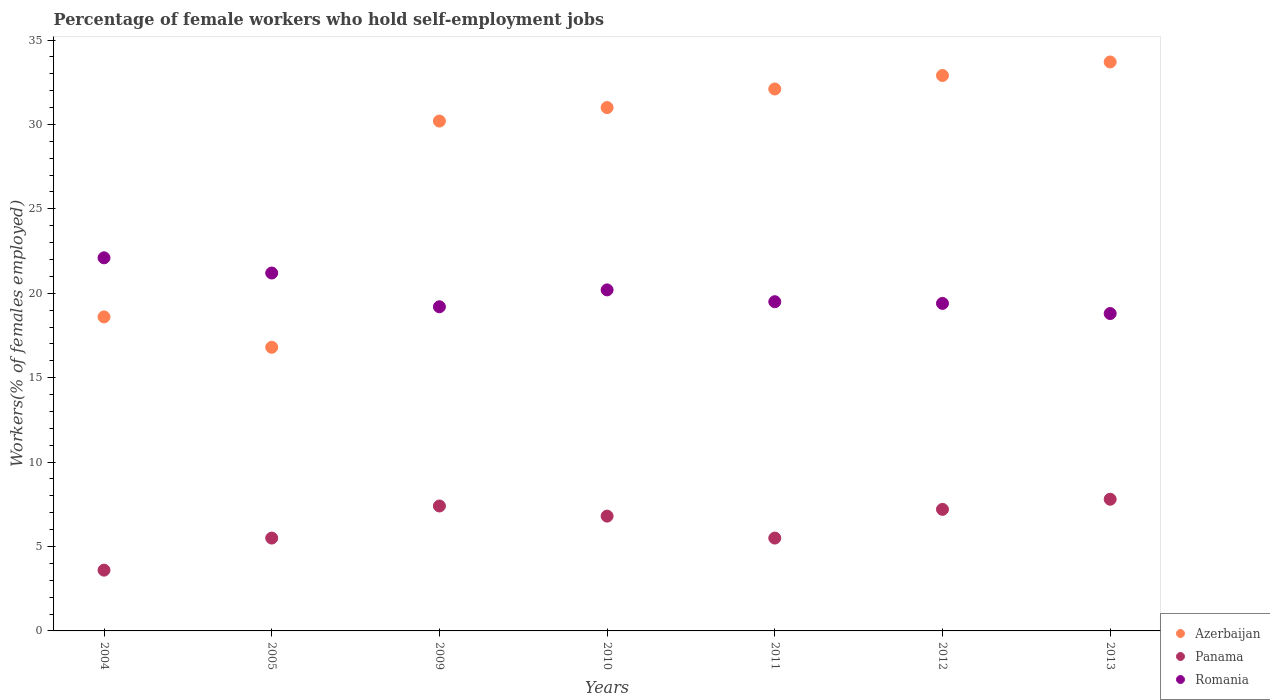Across all years, what is the maximum percentage of self-employed female workers in Panama?
Make the answer very short. 7.8. Across all years, what is the minimum percentage of self-employed female workers in Romania?
Offer a terse response. 18.8. In which year was the percentage of self-employed female workers in Romania maximum?
Offer a very short reply. 2004. What is the total percentage of self-employed female workers in Azerbaijan in the graph?
Give a very brief answer. 195.3. What is the difference between the percentage of self-employed female workers in Panama in 2011 and that in 2012?
Your answer should be very brief. -1.7. What is the difference between the percentage of self-employed female workers in Panama in 2011 and the percentage of self-employed female workers in Romania in 2009?
Give a very brief answer. -13.7. What is the average percentage of self-employed female workers in Panama per year?
Provide a short and direct response. 6.26. In the year 2013, what is the difference between the percentage of self-employed female workers in Azerbaijan and percentage of self-employed female workers in Panama?
Your response must be concise. 25.9. What is the ratio of the percentage of self-employed female workers in Romania in 2011 to that in 2012?
Provide a short and direct response. 1.01. Is the percentage of self-employed female workers in Romania in 2005 less than that in 2009?
Provide a succinct answer. No. What is the difference between the highest and the second highest percentage of self-employed female workers in Azerbaijan?
Your response must be concise. 0.8. What is the difference between the highest and the lowest percentage of self-employed female workers in Panama?
Ensure brevity in your answer.  4.2. In how many years, is the percentage of self-employed female workers in Panama greater than the average percentage of self-employed female workers in Panama taken over all years?
Offer a terse response. 4. Does the percentage of self-employed female workers in Romania monotonically increase over the years?
Your response must be concise. No. Is the percentage of self-employed female workers in Azerbaijan strictly greater than the percentage of self-employed female workers in Panama over the years?
Offer a terse response. Yes. Is the percentage of self-employed female workers in Panama strictly less than the percentage of self-employed female workers in Romania over the years?
Ensure brevity in your answer.  Yes. How many years are there in the graph?
Ensure brevity in your answer.  7. Are the values on the major ticks of Y-axis written in scientific E-notation?
Your answer should be very brief. No. Where does the legend appear in the graph?
Ensure brevity in your answer.  Bottom right. How many legend labels are there?
Provide a short and direct response. 3. How are the legend labels stacked?
Give a very brief answer. Vertical. What is the title of the graph?
Ensure brevity in your answer.  Percentage of female workers who hold self-employment jobs. What is the label or title of the Y-axis?
Give a very brief answer. Workers(% of females employed). What is the Workers(% of females employed) in Azerbaijan in 2004?
Your answer should be compact. 18.6. What is the Workers(% of females employed) of Panama in 2004?
Your answer should be very brief. 3.6. What is the Workers(% of females employed) of Romania in 2004?
Give a very brief answer. 22.1. What is the Workers(% of females employed) in Azerbaijan in 2005?
Provide a short and direct response. 16.8. What is the Workers(% of females employed) of Romania in 2005?
Provide a short and direct response. 21.2. What is the Workers(% of females employed) in Azerbaijan in 2009?
Offer a very short reply. 30.2. What is the Workers(% of females employed) in Panama in 2009?
Make the answer very short. 7.4. What is the Workers(% of females employed) of Romania in 2009?
Offer a very short reply. 19.2. What is the Workers(% of females employed) in Panama in 2010?
Ensure brevity in your answer.  6.8. What is the Workers(% of females employed) of Romania in 2010?
Offer a terse response. 20.2. What is the Workers(% of females employed) of Azerbaijan in 2011?
Provide a short and direct response. 32.1. What is the Workers(% of females employed) in Azerbaijan in 2012?
Ensure brevity in your answer.  32.9. What is the Workers(% of females employed) of Panama in 2012?
Your response must be concise. 7.2. What is the Workers(% of females employed) in Romania in 2012?
Ensure brevity in your answer.  19.4. What is the Workers(% of females employed) of Azerbaijan in 2013?
Provide a short and direct response. 33.7. What is the Workers(% of females employed) in Panama in 2013?
Your response must be concise. 7.8. What is the Workers(% of females employed) of Romania in 2013?
Ensure brevity in your answer.  18.8. Across all years, what is the maximum Workers(% of females employed) in Azerbaijan?
Your response must be concise. 33.7. Across all years, what is the maximum Workers(% of females employed) of Panama?
Ensure brevity in your answer.  7.8. Across all years, what is the maximum Workers(% of females employed) of Romania?
Make the answer very short. 22.1. Across all years, what is the minimum Workers(% of females employed) in Azerbaijan?
Offer a very short reply. 16.8. Across all years, what is the minimum Workers(% of females employed) in Panama?
Ensure brevity in your answer.  3.6. Across all years, what is the minimum Workers(% of females employed) in Romania?
Your response must be concise. 18.8. What is the total Workers(% of females employed) of Azerbaijan in the graph?
Keep it short and to the point. 195.3. What is the total Workers(% of females employed) in Panama in the graph?
Your answer should be compact. 43.8. What is the total Workers(% of females employed) of Romania in the graph?
Provide a succinct answer. 140.4. What is the difference between the Workers(% of females employed) in Panama in 2004 and that in 2005?
Keep it short and to the point. -1.9. What is the difference between the Workers(% of females employed) in Azerbaijan in 2004 and that in 2010?
Your response must be concise. -12.4. What is the difference between the Workers(% of females employed) in Romania in 2004 and that in 2010?
Offer a terse response. 1.9. What is the difference between the Workers(% of females employed) in Romania in 2004 and that in 2011?
Keep it short and to the point. 2.6. What is the difference between the Workers(% of females employed) of Azerbaijan in 2004 and that in 2012?
Keep it short and to the point. -14.3. What is the difference between the Workers(% of females employed) of Romania in 2004 and that in 2012?
Provide a succinct answer. 2.7. What is the difference between the Workers(% of females employed) of Azerbaijan in 2004 and that in 2013?
Your answer should be compact. -15.1. What is the difference between the Workers(% of females employed) of Panama in 2004 and that in 2013?
Keep it short and to the point. -4.2. What is the difference between the Workers(% of females employed) in Romania in 2004 and that in 2013?
Your answer should be compact. 3.3. What is the difference between the Workers(% of females employed) of Romania in 2005 and that in 2009?
Offer a very short reply. 2. What is the difference between the Workers(% of females employed) in Romania in 2005 and that in 2010?
Make the answer very short. 1. What is the difference between the Workers(% of females employed) in Azerbaijan in 2005 and that in 2011?
Provide a succinct answer. -15.3. What is the difference between the Workers(% of females employed) in Panama in 2005 and that in 2011?
Provide a succinct answer. 0. What is the difference between the Workers(% of females employed) of Azerbaijan in 2005 and that in 2012?
Your response must be concise. -16.1. What is the difference between the Workers(% of females employed) in Panama in 2005 and that in 2012?
Make the answer very short. -1.7. What is the difference between the Workers(% of females employed) in Azerbaijan in 2005 and that in 2013?
Your answer should be very brief. -16.9. What is the difference between the Workers(% of females employed) of Panama in 2005 and that in 2013?
Your answer should be compact. -2.3. What is the difference between the Workers(% of females employed) in Romania in 2005 and that in 2013?
Your answer should be very brief. 2.4. What is the difference between the Workers(% of females employed) in Romania in 2009 and that in 2012?
Offer a terse response. -0.2. What is the difference between the Workers(% of females employed) of Azerbaijan in 2009 and that in 2013?
Your answer should be compact. -3.5. What is the difference between the Workers(% of females employed) in Panama in 2009 and that in 2013?
Make the answer very short. -0.4. What is the difference between the Workers(% of females employed) in Romania in 2009 and that in 2013?
Give a very brief answer. 0.4. What is the difference between the Workers(% of females employed) of Azerbaijan in 2010 and that in 2011?
Ensure brevity in your answer.  -1.1. What is the difference between the Workers(% of females employed) of Panama in 2010 and that in 2011?
Offer a very short reply. 1.3. What is the difference between the Workers(% of females employed) of Romania in 2010 and that in 2011?
Keep it short and to the point. 0.7. What is the difference between the Workers(% of females employed) in Panama in 2010 and that in 2012?
Make the answer very short. -0.4. What is the difference between the Workers(% of females employed) of Azerbaijan in 2010 and that in 2013?
Provide a succinct answer. -2.7. What is the difference between the Workers(% of females employed) in Azerbaijan in 2011 and that in 2013?
Offer a very short reply. -1.6. What is the difference between the Workers(% of females employed) of Panama in 2011 and that in 2013?
Make the answer very short. -2.3. What is the difference between the Workers(% of females employed) of Romania in 2011 and that in 2013?
Offer a very short reply. 0.7. What is the difference between the Workers(% of females employed) of Azerbaijan in 2012 and that in 2013?
Give a very brief answer. -0.8. What is the difference between the Workers(% of females employed) of Azerbaijan in 2004 and the Workers(% of females employed) of Romania in 2005?
Provide a short and direct response. -2.6. What is the difference between the Workers(% of females employed) of Panama in 2004 and the Workers(% of females employed) of Romania in 2005?
Keep it short and to the point. -17.6. What is the difference between the Workers(% of females employed) in Panama in 2004 and the Workers(% of females employed) in Romania in 2009?
Give a very brief answer. -15.6. What is the difference between the Workers(% of females employed) of Azerbaijan in 2004 and the Workers(% of females employed) of Panama in 2010?
Ensure brevity in your answer.  11.8. What is the difference between the Workers(% of females employed) of Panama in 2004 and the Workers(% of females employed) of Romania in 2010?
Your answer should be compact. -16.6. What is the difference between the Workers(% of females employed) of Azerbaijan in 2004 and the Workers(% of females employed) of Panama in 2011?
Ensure brevity in your answer.  13.1. What is the difference between the Workers(% of females employed) in Azerbaijan in 2004 and the Workers(% of females employed) in Romania in 2011?
Your response must be concise. -0.9. What is the difference between the Workers(% of females employed) of Panama in 2004 and the Workers(% of females employed) of Romania in 2011?
Give a very brief answer. -15.9. What is the difference between the Workers(% of females employed) in Panama in 2004 and the Workers(% of females employed) in Romania in 2012?
Your answer should be very brief. -15.8. What is the difference between the Workers(% of females employed) of Panama in 2004 and the Workers(% of females employed) of Romania in 2013?
Your response must be concise. -15.2. What is the difference between the Workers(% of females employed) of Azerbaijan in 2005 and the Workers(% of females employed) of Romania in 2009?
Give a very brief answer. -2.4. What is the difference between the Workers(% of females employed) in Panama in 2005 and the Workers(% of females employed) in Romania in 2009?
Give a very brief answer. -13.7. What is the difference between the Workers(% of females employed) of Azerbaijan in 2005 and the Workers(% of females employed) of Romania in 2010?
Your response must be concise. -3.4. What is the difference between the Workers(% of females employed) in Panama in 2005 and the Workers(% of females employed) in Romania in 2010?
Your response must be concise. -14.7. What is the difference between the Workers(% of females employed) of Azerbaijan in 2005 and the Workers(% of females employed) of Romania in 2011?
Give a very brief answer. -2.7. What is the difference between the Workers(% of females employed) of Azerbaijan in 2005 and the Workers(% of females employed) of Romania in 2012?
Give a very brief answer. -2.6. What is the difference between the Workers(% of females employed) in Azerbaijan in 2005 and the Workers(% of females employed) in Panama in 2013?
Offer a very short reply. 9. What is the difference between the Workers(% of females employed) of Azerbaijan in 2005 and the Workers(% of females employed) of Romania in 2013?
Your answer should be very brief. -2. What is the difference between the Workers(% of females employed) of Azerbaijan in 2009 and the Workers(% of females employed) of Panama in 2010?
Provide a succinct answer. 23.4. What is the difference between the Workers(% of females employed) of Azerbaijan in 2009 and the Workers(% of females employed) of Romania in 2010?
Provide a succinct answer. 10. What is the difference between the Workers(% of females employed) of Azerbaijan in 2009 and the Workers(% of females employed) of Panama in 2011?
Provide a succinct answer. 24.7. What is the difference between the Workers(% of females employed) of Azerbaijan in 2009 and the Workers(% of females employed) of Panama in 2012?
Your answer should be very brief. 23. What is the difference between the Workers(% of females employed) of Azerbaijan in 2009 and the Workers(% of females employed) of Romania in 2012?
Offer a terse response. 10.8. What is the difference between the Workers(% of females employed) in Azerbaijan in 2009 and the Workers(% of females employed) in Panama in 2013?
Provide a succinct answer. 22.4. What is the difference between the Workers(% of females employed) in Azerbaijan in 2009 and the Workers(% of females employed) in Romania in 2013?
Provide a succinct answer. 11.4. What is the difference between the Workers(% of females employed) of Azerbaijan in 2010 and the Workers(% of females employed) of Romania in 2011?
Your answer should be compact. 11.5. What is the difference between the Workers(% of females employed) of Panama in 2010 and the Workers(% of females employed) of Romania in 2011?
Your response must be concise. -12.7. What is the difference between the Workers(% of females employed) in Azerbaijan in 2010 and the Workers(% of females employed) in Panama in 2012?
Make the answer very short. 23.8. What is the difference between the Workers(% of females employed) of Azerbaijan in 2010 and the Workers(% of females employed) of Romania in 2012?
Provide a succinct answer. 11.6. What is the difference between the Workers(% of females employed) of Panama in 2010 and the Workers(% of females employed) of Romania in 2012?
Make the answer very short. -12.6. What is the difference between the Workers(% of females employed) of Azerbaijan in 2010 and the Workers(% of females employed) of Panama in 2013?
Offer a terse response. 23.2. What is the difference between the Workers(% of females employed) of Azerbaijan in 2010 and the Workers(% of females employed) of Romania in 2013?
Your answer should be compact. 12.2. What is the difference between the Workers(% of females employed) of Panama in 2010 and the Workers(% of females employed) of Romania in 2013?
Provide a succinct answer. -12. What is the difference between the Workers(% of females employed) in Azerbaijan in 2011 and the Workers(% of females employed) in Panama in 2012?
Offer a very short reply. 24.9. What is the difference between the Workers(% of females employed) of Azerbaijan in 2011 and the Workers(% of females employed) of Panama in 2013?
Make the answer very short. 24.3. What is the difference between the Workers(% of females employed) in Azerbaijan in 2011 and the Workers(% of females employed) in Romania in 2013?
Your answer should be compact. 13.3. What is the difference between the Workers(% of females employed) in Panama in 2011 and the Workers(% of females employed) in Romania in 2013?
Your response must be concise. -13.3. What is the difference between the Workers(% of females employed) in Azerbaijan in 2012 and the Workers(% of females employed) in Panama in 2013?
Make the answer very short. 25.1. What is the difference between the Workers(% of females employed) of Panama in 2012 and the Workers(% of females employed) of Romania in 2013?
Make the answer very short. -11.6. What is the average Workers(% of females employed) of Azerbaijan per year?
Provide a succinct answer. 27.9. What is the average Workers(% of females employed) of Panama per year?
Offer a terse response. 6.26. What is the average Workers(% of females employed) of Romania per year?
Offer a very short reply. 20.06. In the year 2004, what is the difference between the Workers(% of females employed) in Azerbaijan and Workers(% of females employed) in Panama?
Give a very brief answer. 15. In the year 2004, what is the difference between the Workers(% of females employed) of Panama and Workers(% of females employed) of Romania?
Ensure brevity in your answer.  -18.5. In the year 2005, what is the difference between the Workers(% of females employed) of Azerbaijan and Workers(% of females employed) of Panama?
Your answer should be very brief. 11.3. In the year 2005, what is the difference between the Workers(% of females employed) of Panama and Workers(% of females employed) of Romania?
Give a very brief answer. -15.7. In the year 2009, what is the difference between the Workers(% of females employed) of Azerbaijan and Workers(% of females employed) of Panama?
Your answer should be very brief. 22.8. In the year 2010, what is the difference between the Workers(% of females employed) in Azerbaijan and Workers(% of females employed) in Panama?
Ensure brevity in your answer.  24.2. In the year 2010, what is the difference between the Workers(% of females employed) in Azerbaijan and Workers(% of females employed) in Romania?
Offer a very short reply. 10.8. In the year 2011, what is the difference between the Workers(% of females employed) of Azerbaijan and Workers(% of females employed) of Panama?
Make the answer very short. 26.6. In the year 2011, what is the difference between the Workers(% of females employed) in Panama and Workers(% of females employed) in Romania?
Your answer should be compact. -14. In the year 2012, what is the difference between the Workers(% of females employed) in Azerbaijan and Workers(% of females employed) in Panama?
Provide a succinct answer. 25.7. In the year 2012, what is the difference between the Workers(% of females employed) in Panama and Workers(% of females employed) in Romania?
Ensure brevity in your answer.  -12.2. In the year 2013, what is the difference between the Workers(% of females employed) in Azerbaijan and Workers(% of females employed) in Panama?
Offer a very short reply. 25.9. What is the ratio of the Workers(% of females employed) in Azerbaijan in 2004 to that in 2005?
Offer a very short reply. 1.11. What is the ratio of the Workers(% of females employed) of Panama in 2004 to that in 2005?
Give a very brief answer. 0.65. What is the ratio of the Workers(% of females employed) in Romania in 2004 to that in 2005?
Your answer should be compact. 1.04. What is the ratio of the Workers(% of females employed) of Azerbaijan in 2004 to that in 2009?
Ensure brevity in your answer.  0.62. What is the ratio of the Workers(% of females employed) in Panama in 2004 to that in 2009?
Offer a very short reply. 0.49. What is the ratio of the Workers(% of females employed) in Romania in 2004 to that in 2009?
Your response must be concise. 1.15. What is the ratio of the Workers(% of females employed) of Azerbaijan in 2004 to that in 2010?
Offer a terse response. 0.6. What is the ratio of the Workers(% of females employed) in Panama in 2004 to that in 2010?
Make the answer very short. 0.53. What is the ratio of the Workers(% of females employed) in Romania in 2004 to that in 2010?
Give a very brief answer. 1.09. What is the ratio of the Workers(% of females employed) in Azerbaijan in 2004 to that in 2011?
Your response must be concise. 0.58. What is the ratio of the Workers(% of females employed) of Panama in 2004 to that in 2011?
Provide a succinct answer. 0.65. What is the ratio of the Workers(% of females employed) in Romania in 2004 to that in 2011?
Your answer should be very brief. 1.13. What is the ratio of the Workers(% of females employed) in Azerbaijan in 2004 to that in 2012?
Ensure brevity in your answer.  0.57. What is the ratio of the Workers(% of females employed) in Panama in 2004 to that in 2012?
Your answer should be compact. 0.5. What is the ratio of the Workers(% of females employed) of Romania in 2004 to that in 2012?
Your answer should be compact. 1.14. What is the ratio of the Workers(% of females employed) of Azerbaijan in 2004 to that in 2013?
Your answer should be very brief. 0.55. What is the ratio of the Workers(% of females employed) of Panama in 2004 to that in 2013?
Your answer should be very brief. 0.46. What is the ratio of the Workers(% of females employed) in Romania in 2004 to that in 2013?
Your answer should be compact. 1.18. What is the ratio of the Workers(% of females employed) of Azerbaijan in 2005 to that in 2009?
Give a very brief answer. 0.56. What is the ratio of the Workers(% of females employed) in Panama in 2005 to that in 2009?
Your answer should be compact. 0.74. What is the ratio of the Workers(% of females employed) of Romania in 2005 to that in 2009?
Your response must be concise. 1.1. What is the ratio of the Workers(% of females employed) in Azerbaijan in 2005 to that in 2010?
Your answer should be very brief. 0.54. What is the ratio of the Workers(% of females employed) of Panama in 2005 to that in 2010?
Provide a short and direct response. 0.81. What is the ratio of the Workers(% of females employed) in Romania in 2005 to that in 2010?
Your answer should be compact. 1.05. What is the ratio of the Workers(% of females employed) of Azerbaijan in 2005 to that in 2011?
Make the answer very short. 0.52. What is the ratio of the Workers(% of females employed) of Romania in 2005 to that in 2011?
Provide a short and direct response. 1.09. What is the ratio of the Workers(% of females employed) of Azerbaijan in 2005 to that in 2012?
Provide a succinct answer. 0.51. What is the ratio of the Workers(% of females employed) of Panama in 2005 to that in 2012?
Keep it short and to the point. 0.76. What is the ratio of the Workers(% of females employed) in Romania in 2005 to that in 2012?
Offer a terse response. 1.09. What is the ratio of the Workers(% of females employed) in Azerbaijan in 2005 to that in 2013?
Provide a short and direct response. 0.5. What is the ratio of the Workers(% of females employed) of Panama in 2005 to that in 2013?
Keep it short and to the point. 0.71. What is the ratio of the Workers(% of females employed) in Romania in 2005 to that in 2013?
Offer a very short reply. 1.13. What is the ratio of the Workers(% of females employed) of Azerbaijan in 2009 to that in 2010?
Provide a succinct answer. 0.97. What is the ratio of the Workers(% of females employed) of Panama in 2009 to that in 2010?
Your answer should be compact. 1.09. What is the ratio of the Workers(% of females employed) of Romania in 2009 to that in 2010?
Keep it short and to the point. 0.95. What is the ratio of the Workers(% of females employed) in Azerbaijan in 2009 to that in 2011?
Provide a short and direct response. 0.94. What is the ratio of the Workers(% of females employed) in Panama in 2009 to that in 2011?
Offer a very short reply. 1.35. What is the ratio of the Workers(% of females employed) of Romania in 2009 to that in 2011?
Offer a very short reply. 0.98. What is the ratio of the Workers(% of females employed) of Azerbaijan in 2009 to that in 2012?
Your response must be concise. 0.92. What is the ratio of the Workers(% of females employed) in Panama in 2009 to that in 2012?
Offer a terse response. 1.03. What is the ratio of the Workers(% of females employed) in Azerbaijan in 2009 to that in 2013?
Give a very brief answer. 0.9. What is the ratio of the Workers(% of females employed) in Panama in 2009 to that in 2013?
Your answer should be compact. 0.95. What is the ratio of the Workers(% of females employed) in Romania in 2009 to that in 2013?
Your answer should be compact. 1.02. What is the ratio of the Workers(% of females employed) in Azerbaijan in 2010 to that in 2011?
Provide a succinct answer. 0.97. What is the ratio of the Workers(% of females employed) in Panama in 2010 to that in 2011?
Give a very brief answer. 1.24. What is the ratio of the Workers(% of females employed) in Romania in 2010 to that in 2011?
Your answer should be very brief. 1.04. What is the ratio of the Workers(% of females employed) in Azerbaijan in 2010 to that in 2012?
Offer a very short reply. 0.94. What is the ratio of the Workers(% of females employed) of Panama in 2010 to that in 2012?
Your answer should be very brief. 0.94. What is the ratio of the Workers(% of females employed) in Romania in 2010 to that in 2012?
Your response must be concise. 1.04. What is the ratio of the Workers(% of females employed) of Azerbaijan in 2010 to that in 2013?
Provide a short and direct response. 0.92. What is the ratio of the Workers(% of females employed) of Panama in 2010 to that in 2013?
Provide a short and direct response. 0.87. What is the ratio of the Workers(% of females employed) of Romania in 2010 to that in 2013?
Offer a very short reply. 1.07. What is the ratio of the Workers(% of females employed) in Azerbaijan in 2011 to that in 2012?
Ensure brevity in your answer.  0.98. What is the ratio of the Workers(% of females employed) of Panama in 2011 to that in 2012?
Provide a succinct answer. 0.76. What is the ratio of the Workers(% of females employed) of Romania in 2011 to that in 2012?
Your answer should be compact. 1.01. What is the ratio of the Workers(% of females employed) in Azerbaijan in 2011 to that in 2013?
Make the answer very short. 0.95. What is the ratio of the Workers(% of females employed) of Panama in 2011 to that in 2013?
Keep it short and to the point. 0.71. What is the ratio of the Workers(% of females employed) of Romania in 2011 to that in 2013?
Ensure brevity in your answer.  1.04. What is the ratio of the Workers(% of females employed) in Azerbaijan in 2012 to that in 2013?
Your answer should be very brief. 0.98. What is the ratio of the Workers(% of females employed) in Panama in 2012 to that in 2013?
Give a very brief answer. 0.92. What is the ratio of the Workers(% of females employed) in Romania in 2012 to that in 2013?
Keep it short and to the point. 1.03. What is the difference between the highest and the second highest Workers(% of females employed) of Panama?
Make the answer very short. 0.4. 